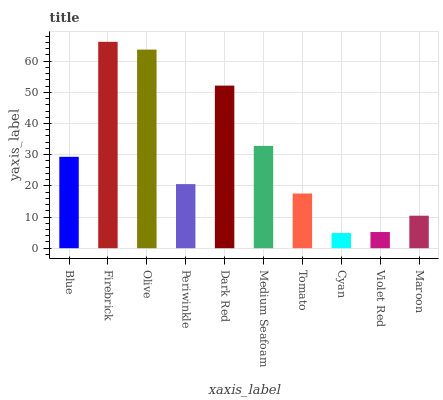Is Cyan the minimum?
Answer yes or no. Yes. Is Firebrick the maximum?
Answer yes or no. Yes. Is Olive the minimum?
Answer yes or no. No. Is Olive the maximum?
Answer yes or no. No. Is Firebrick greater than Olive?
Answer yes or no. Yes. Is Olive less than Firebrick?
Answer yes or no. Yes. Is Olive greater than Firebrick?
Answer yes or no. No. Is Firebrick less than Olive?
Answer yes or no. No. Is Blue the high median?
Answer yes or no. Yes. Is Periwinkle the low median?
Answer yes or no. Yes. Is Dark Red the high median?
Answer yes or no. No. Is Firebrick the low median?
Answer yes or no. No. 